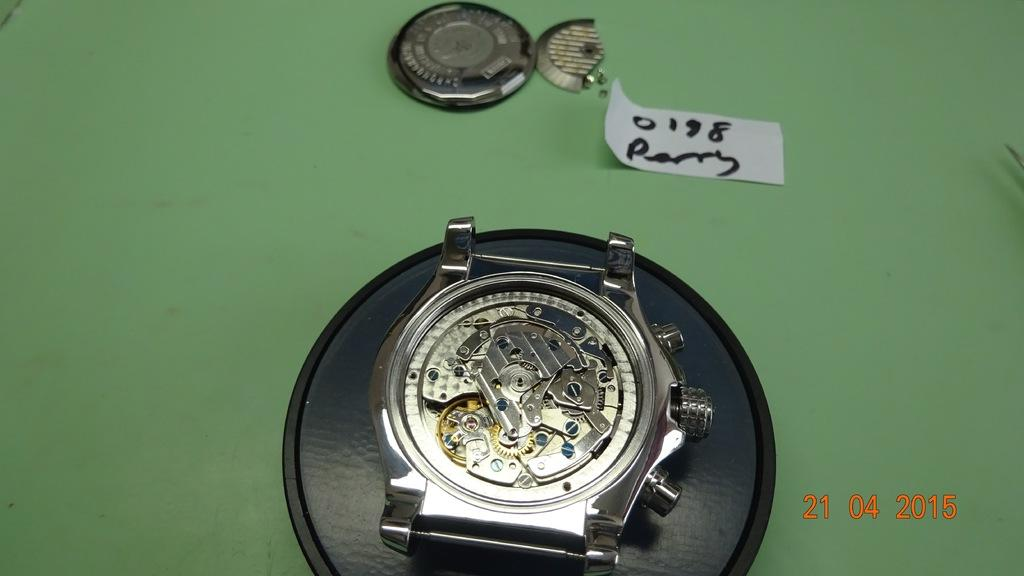<image>
Render a clear and concise summary of the photo. the number 21 is next to a watch like item 